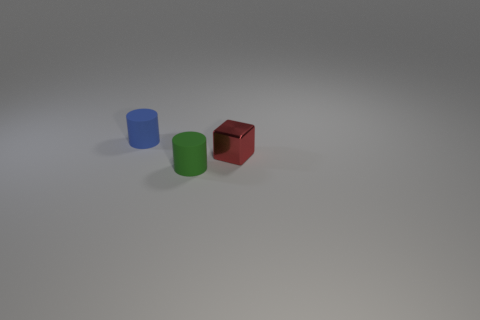Add 3 green cylinders. How many objects exist? 6 Subtract all cylinders. How many objects are left? 1 Subtract 1 blocks. How many blocks are left? 0 Subtract all yellow cylinders. Subtract all green spheres. How many cylinders are left? 2 Subtract all cylinders. Subtract all tiny purple matte objects. How many objects are left? 1 Add 3 blue cylinders. How many blue cylinders are left? 4 Add 3 matte things. How many matte things exist? 5 Subtract 0 yellow cylinders. How many objects are left? 3 